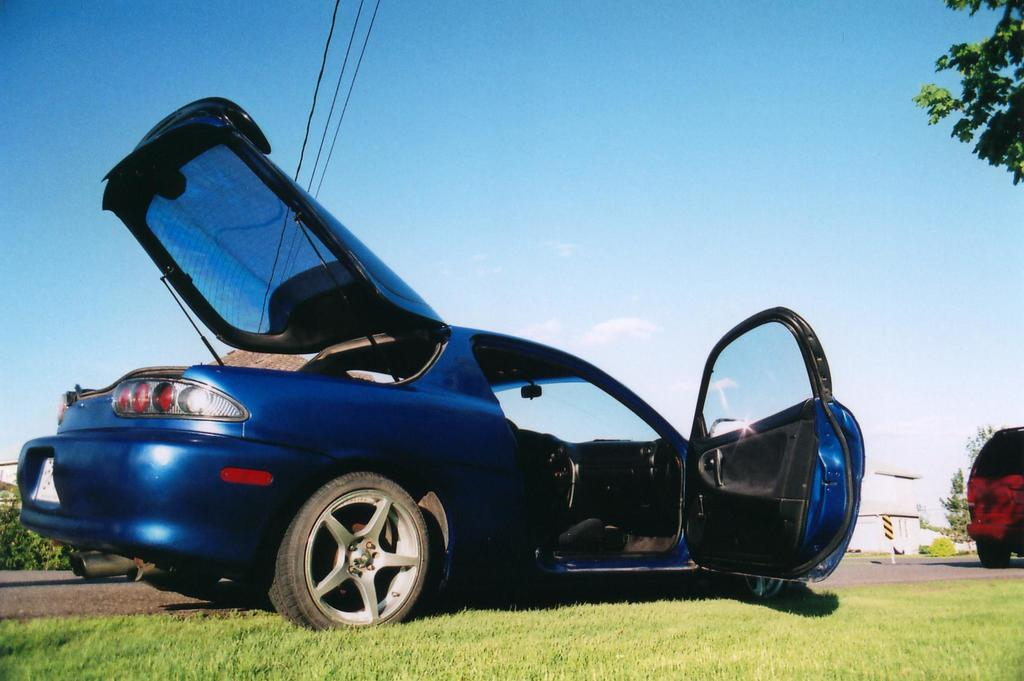What type of vehicle is in the image? There is a blue car in the image. What feature does the car have? The car has doors. What type of terrain is visible at the bottom of the image? There is grass at the bottom of the image. What is visible at the top of the image? The sky is visible at the top of the image. Where is the whip stored in the image? There is no whip present in the image. What type of underground space is visible in the image? There is no cellar visible in the image. 